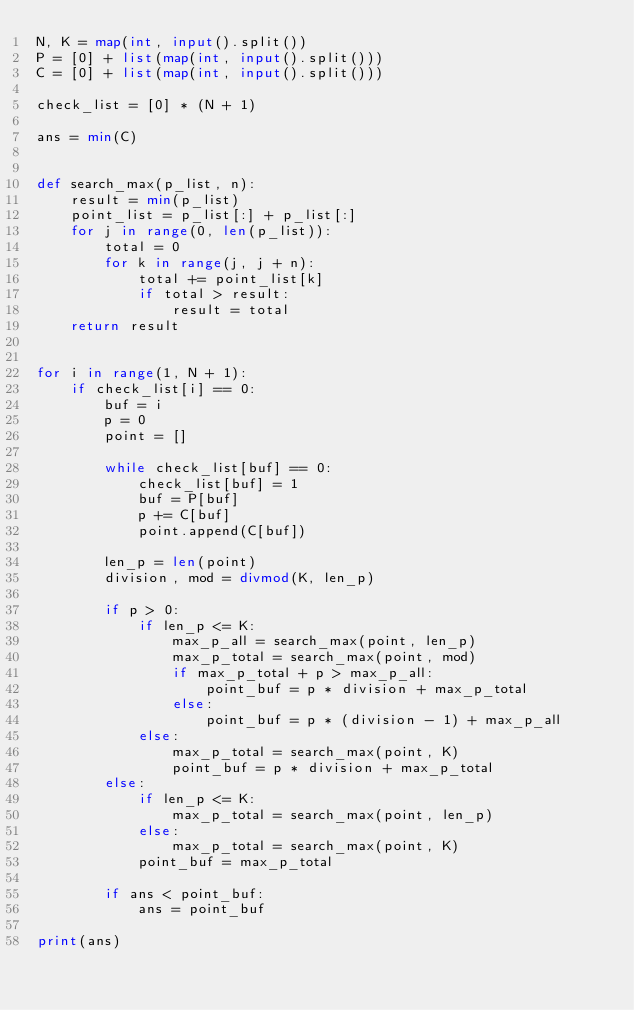Convert code to text. <code><loc_0><loc_0><loc_500><loc_500><_Python_>N, K = map(int, input().split())
P = [0] + list(map(int, input().split()))
C = [0] + list(map(int, input().split()))

check_list = [0] * (N + 1)

ans = min(C)


def search_max(p_list, n):
    result = min(p_list)
    point_list = p_list[:] + p_list[:]
    for j in range(0, len(p_list)):
        total = 0
        for k in range(j, j + n):
            total += point_list[k]
            if total > result:
                result = total
    return result


for i in range(1, N + 1):
    if check_list[i] == 0:
        buf = i
        p = 0
        point = []

        while check_list[buf] == 0:
            check_list[buf] = 1
            buf = P[buf]
            p += C[buf]
            point.append(C[buf])

        len_p = len(point)
        division, mod = divmod(K, len_p)

        if p > 0:
            if len_p <= K:
                max_p_all = search_max(point, len_p)
                max_p_total = search_max(point, mod)
                if max_p_total + p > max_p_all:
                    point_buf = p * division + max_p_total
                else:
                    point_buf = p * (division - 1) + max_p_all
            else:
                max_p_total = search_max(point, K)
                point_buf = p * division + max_p_total
        else:
            if len_p <= K:
                max_p_total = search_max(point, len_p)
            else:
                max_p_total = search_max(point, K)
            point_buf = max_p_total

        if ans < point_buf:
            ans = point_buf

print(ans)</code> 